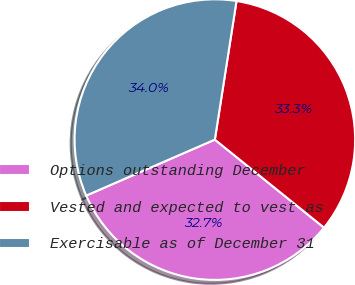<chart> <loc_0><loc_0><loc_500><loc_500><pie_chart><fcel>Options outstanding December<fcel>Vested and expected to vest as<fcel>Exercisable as of December 31<nl><fcel>32.67%<fcel>33.33%<fcel>34.0%<nl></chart> 